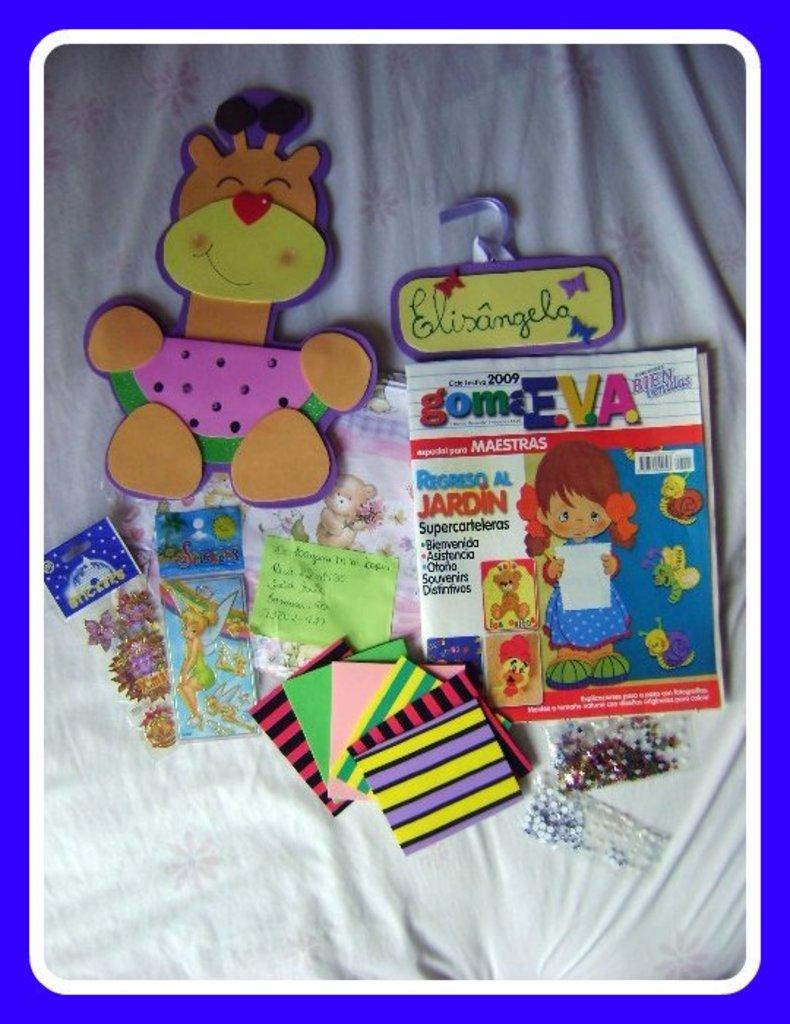Could you give a brief overview of what you see in this image? In this image in the middle, there are books, toys, papers, stickers and many items. At the bottom there is a blanket. 